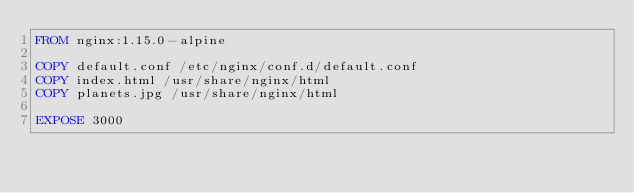Convert code to text. <code><loc_0><loc_0><loc_500><loc_500><_Dockerfile_>FROM nginx:1.15.0-alpine

COPY default.conf /etc/nginx/conf.d/default.conf
COPY index.html /usr/share/nginx/html
COPY planets.jpg /usr/share/nginx/html

EXPOSE 3000
</code> 